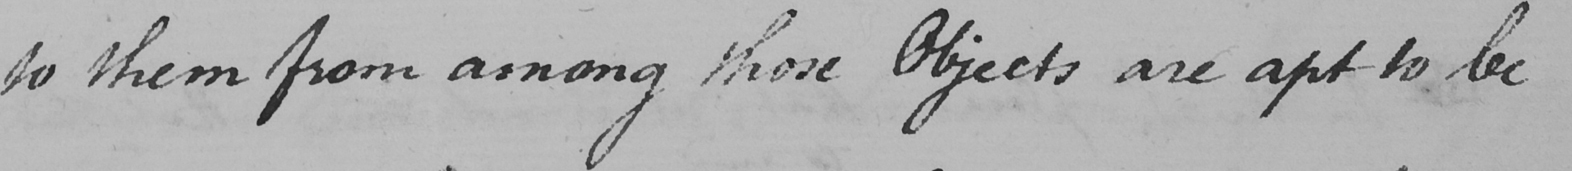Can you tell me what this handwritten text says? to them from among those Objects are apt to be 